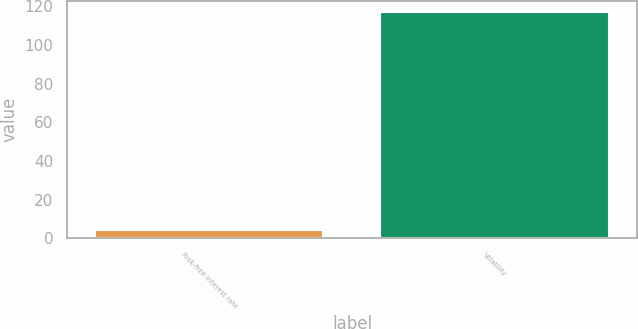Convert chart. <chart><loc_0><loc_0><loc_500><loc_500><bar_chart><fcel>Risk-free interest rate<fcel>Volatility<nl><fcel>4.36<fcel>117<nl></chart> 